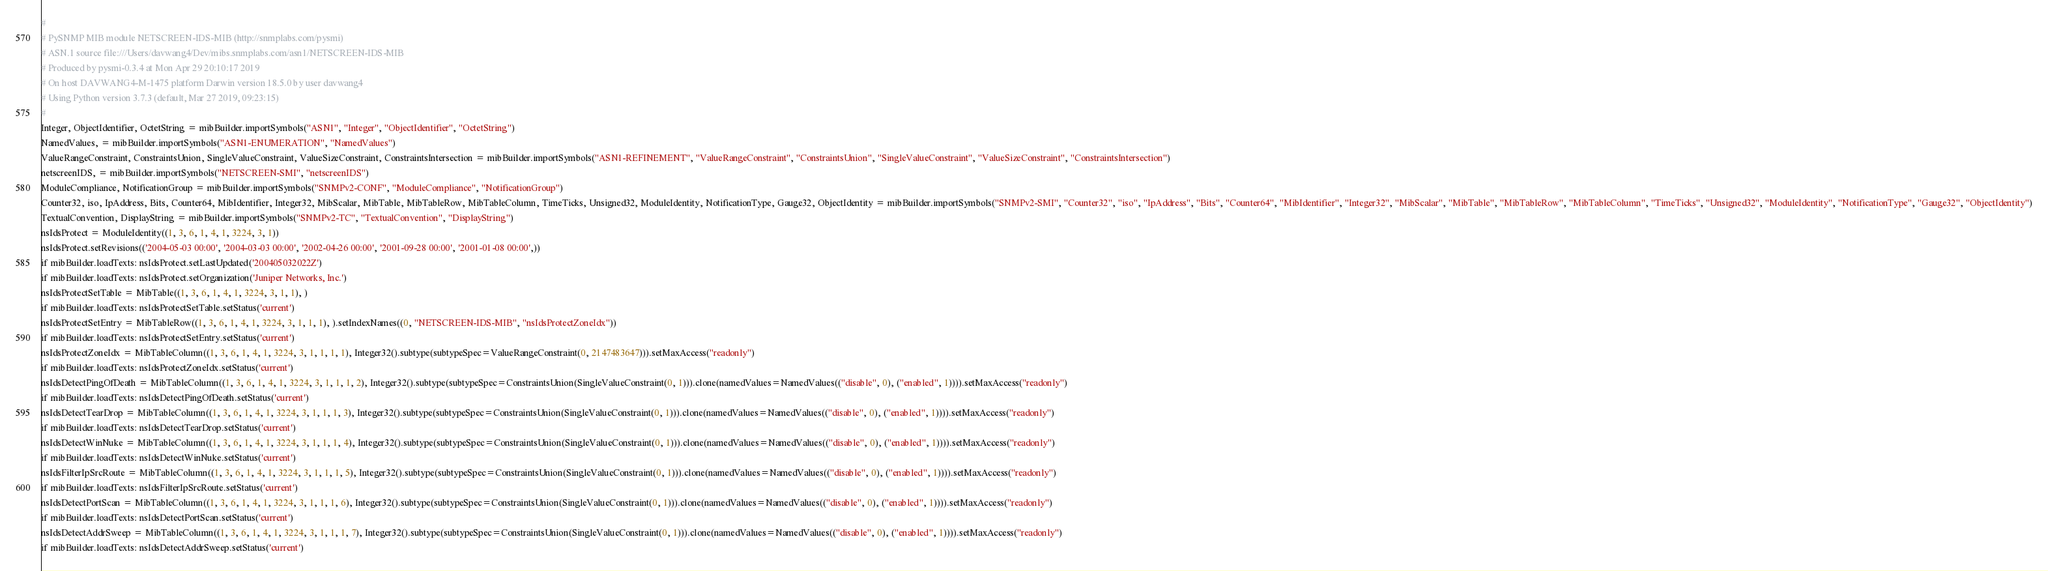Convert code to text. <code><loc_0><loc_0><loc_500><loc_500><_Python_>#
# PySNMP MIB module NETSCREEN-IDS-MIB (http://snmplabs.com/pysmi)
# ASN.1 source file:///Users/davwang4/Dev/mibs.snmplabs.com/asn1/NETSCREEN-IDS-MIB
# Produced by pysmi-0.3.4 at Mon Apr 29 20:10:17 2019
# On host DAVWANG4-M-1475 platform Darwin version 18.5.0 by user davwang4
# Using Python version 3.7.3 (default, Mar 27 2019, 09:23:15) 
#
Integer, ObjectIdentifier, OctetString = mibBuilder.importSymbols("ASN1", "Integer", "ObjectIdentifier", "OctetString")
NamedValues, = mibBuilder.importSymbols("ASN1-ENUMERATION", "NamedValues")
ValueRangeConstraint, ConstraintsUnion, SingleValueConstraint, ValueSizeConstraint, ConstraintsIntersection = mibBuilder.importSymbols("ASN1-REFINEMENT", "ValueRangeConstraint", "ConstraintsUnion", "SingleValueConstraint", "ValueSizeConstraint", "ConstraintsIntersection")
netscreenIDS, = mibBuilder.importSymbols("NETSCREEN-SMI", "netscreenIDS")
ModuleCompliance, NotificationGroup = mibBuilder.importSymbols("SNMPv2-CONF", "ModuleCompliance", "NotificationGroup")
Counter32, iso, IpAddress, Bits, Counter64, MibIdentifier, Integer32, MibScalar, MibTable, MibTableRow, MibTableColumn, TimeTicks, Unsigned32, ModuleIdentity, NotificationType, Gauge32, ObjectIdentity = mibBuilder.importSymbols("SNMPv2-SMI", "Counter32", "iso", "IpAddress", "Bits", "Counter64", "MibIdentifier", "Integer32", "MibScalar", "MibTable", "MibTableRow", "MibTableColumn", "TimeTicks", "Unsigned32", "ModuleIdentity", "NotificationType", "Gauge32", "ObjectIdentity")
TextualConvention, DisplayString = mibBuilder.importSymbols("SNMPv2-TC", "TextualConvention", "DisplayString")
nsIdsProtect = ModuleIdentity((1, 3, 6, 1, 4, 1, 3224, 3, 1))
nsIdsProtect.setRevisions(('2004-05-03 00:00', '2004-03-03 00:00', '2002-04-26 00:00', '2001-09-28 00:00', '2001-01-08 00:00',))
if mibBuilder.loadTexts: nsIdsProtect.setLastUpdated('200405032022Z')
if mibBuilder.loadTexts: nsIdsProtect.setOrganization('Juniper Networks, Inc.')
nsIdsProtectSetTable = MibTable((1, 3, 6, 1, 4, 1, 3224, 3, 1, 1), )
if mibBuilder.loadTexts: nsIdsProtectSetTable.setStatus('current')
nsIdsProtectSetEntry = MibTableRow((1, 3, 6, 1, 4, 1, 3224, 3, 1, 1, 1), ).setIndexNames((0, "NETSCREEN-IDS-MIB", "nsIdsProtectZoneIdx"))
if mibBuilder.loadTexts: nsIdsProtectSetEntry.setStatus('current')
nsIdsProtectZoneIdx = MibTableColumn((1, 3, 6, 1, 4, 1, 3224, 3, 1, 1, 1, 1), Integer32().subtype(subtypeSpec=ValueRangeConstraint(0, 2147483647))).setMaxAccess("readonly")
if mibBuilder.loadTexts: nsIdsProtectZoneIdx.setStatus('current')
nsIdsDetectPingOfDeath = MibTableColumn((1, 3, 6, 1, 4, 1, 3224, 3, 1, 1, 1, 2), Integer32().subtype(subtypeSpec=ConstraintsUnion(SingleValueConstraint(0, 1))).clone(namedValues=NamedValues(("disable", 0), ("enabled", 1)))).setMaxAccess("readonly")
if mibBuilder.loadTexts: nsIdsDetectPingOfDeath.setStatus('current')
nsIdsDetectTearDrop = MibTableColumn((1, 3, 6, 1, 4, 1, 3224, 3, 1, 1, 1, 3), Integer32().subtype(subtypeSpec=ConstraintsUnion(SingleValueConstraint(0, 1))).clone(namedValues=NamedValues(("disable", 0), ("enabled", 1)))).setMaxAccess("readonly")
if mibBuilder.loadTexts: nsIdsDetectTearDrop.setStatus('current')
nsIdsDetectWinNuke = MibTableColumn((1, 3, 6, 1, 4, 1, 3224, 3, 1, 1, 1, 4), Integer32().subtype(subtypeSpec=ConstraintsUnion(SingleValueConstraint(0, 1))).clone(namedValues=NamedValues(("disable", 0), ("enabled", 1)))).setMaxAccess("readonly")
if mibBuilder.loadTexts: nsIdsDetectWinNuke.setStatus('current')
nsIdsFilterIpSrcRoute = MibTableColumn((1, 3, 6, 1, 4, 1, 3224, 3, 1, 1, 1, 5), Integer32().subtype(subtypeSpec=ConstraintsUnion(SingleValueConstraint(0, 1))).clone(namedValues=NamedValues(("disable", 0), ("enabled", 1)))).setMaxAccess("readonly")
if mibBuilder.loadTexts: nsIdsFilterIpSrcRoute.setStatus('current')
nsIdsDetectPortScan = MibTableColumn((1, 3, 6, 1, 4, 1, 3224, 3, 1, 1, 1, 6), Integer32().subtype(subtypeSpec=ConstraintsUnion(SingleValueConstraint(0, 1))).clone(namedValues=NamedValues(("disable", 0), ("enabled", 1)))).setMaxAccess("readonly")
if mibBuilder.loadTexts: nsIdsDetectPortScan.setStatus('current')
nsIdsDetectAddrSweep = MibTableColumn((1, 3, 6, 1, 4, 1, 3224, 3, 1, 1, 1, 7), Integer32().subtype(subtypeSpec=ConstraintsUnion(SingleValueConstraint(0, 1))).clone(namedValues=NamedValues(("disable", 0), ("enabled", 1)))).setMaxAccess("readonly")
if mibBuilder.loadTexts: nsIdsDetectAddrSweep.setStatus('current')</code> 